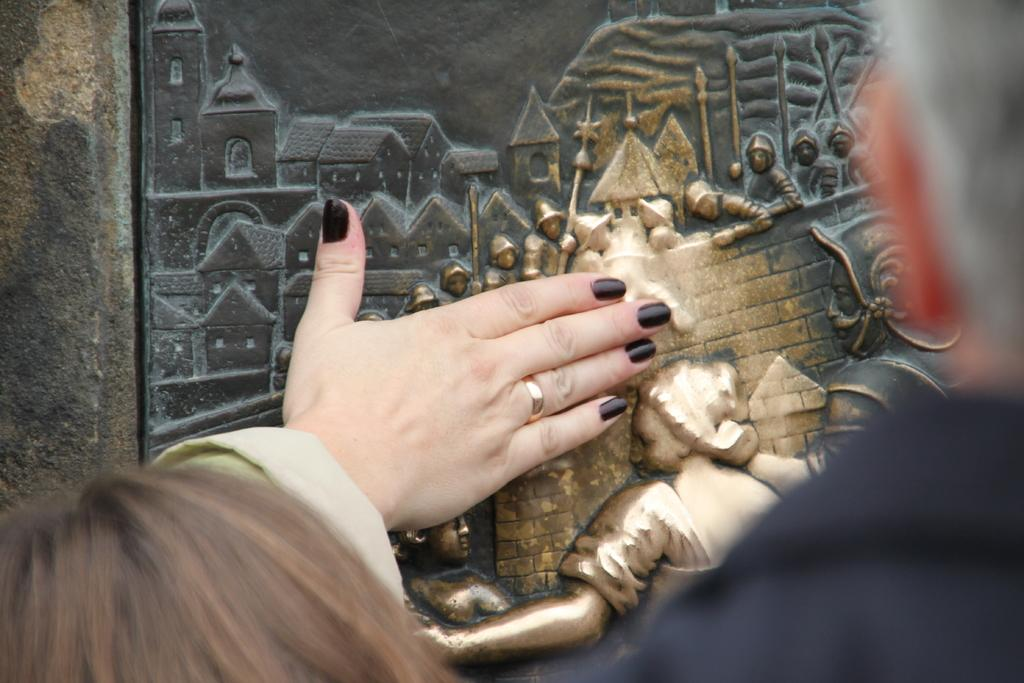What can be seen on the wall in the image? There is a carving on a wall in the image. What is depicted in the carving? A hand of a person is visible on the carving. How many people are in the foreground of the image? There are two people in the foreground of the image. What type of wrench is being used by the person in the image? There is no wrench present in the image; the carving only shows a hand. 